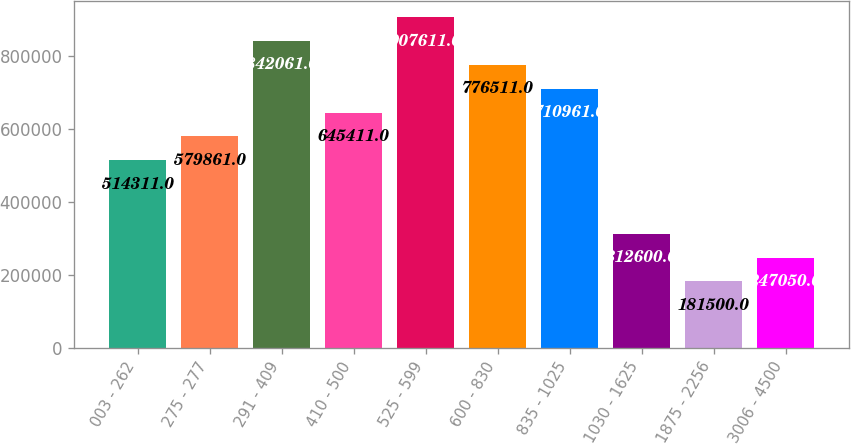Convert chart to OTSL. <chart><loc_0><loc_0><loc_500><loc_500><bar_chart><fcel>003 - 262<fcel>275 - 277<fcel>291 - 409<fcel>410 - 500<fcel>525 - 599<fcel>600 - 830<fcel>835 - 1025<fcel>1030 - 1625<fcel>1875 - 2256<fcel>3006 - 4500<nl><fcel>514311<fcel>579861<fcel>842061<fcel>645411<fcel>907611<fcel>776511<fcel>710961<fcel>312600<fcel>181500<fcel>247050<nl></chart> 